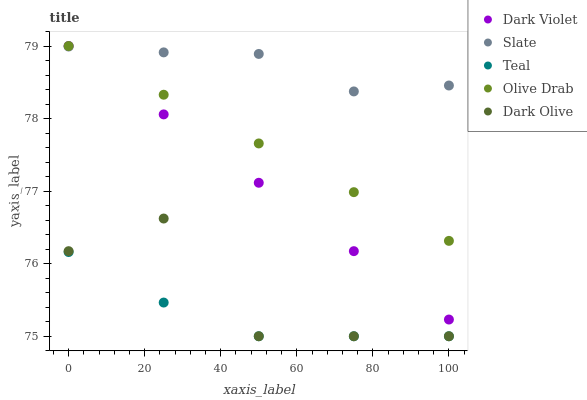Does Teal have the minimum area under the curve?
Answer yes or no. Yes. Does Slate have the maximum area under the curve?
Answer yes or no. Yes. Does Dark Olive have the minimum area under the curve?
Answer yes or no. No. Does Dark Olive have the maximum area under the curve?
Answer yes or no. No. Is Dark Violet the smoothest?
Answer yes or no. Yes. Is Dark Olive the roughest?
Answer yes or no. Yes. Is Slate the smoothest?
Answer yes or no. No. Is Slate the roughest?
Answer yes or no. No. Does Dark Olive have the lowest value?
Answer yes or no. Yes. Does Slate have the lowest value?
Answer yes or no. No. Does Dark Violet have the highest value?
Answer yes or no. Yes. Does Slate have the highest value?
Answer yes or no. No. Is Teal less than Slate?
Answer yes or no. Yes. Is Slate greater than Teal?
Answer yes or no. Yes. Does Slate intersect Dark Violet?
Answer yes or no. Yes. Is Slate less than Dark Violet?
Answer yes or no. No. Is Slate greater than Dark Violet?
Answer yes or no. No. Does Teal intersect Slate?
Answer yes or no. No. 